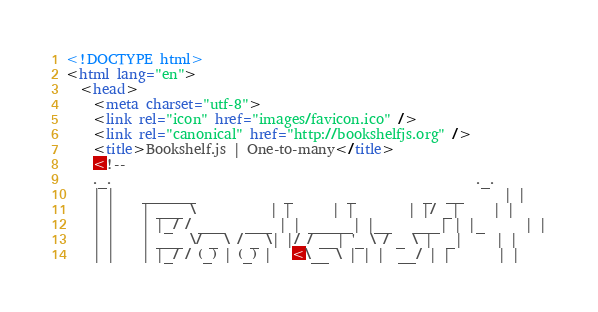Convert code to text. <code><loc_0><loc_0><loc_500><loc_500><_HTML_><!DOCTYPE html>
<html lang="en">
  <head>
    <meta charset="utf-8">
    <link rel="icon" href="images/favicon.ico" />
    <link rel="canonical" href="http://bookshelfjs.org" />
    <title>Bookshelf.js | One-to-many</title>
    <!--
    ._.                                                      ._.
    | |    ______             _        _          _  __      | |
    | |    | ___ \           | |      | |        | |/ _|     | |
    | |    | |_/ / ___   ___ | | _____| |__   ___| | |_      | |
    | |    | ___ \/ _ \ / _ \| |/ / __| '_ \ / _ \ |  _|     | |
    | |    | |_/ / (_) | (_) |   <\__ \ | | |  __/ | |       | |</code> 